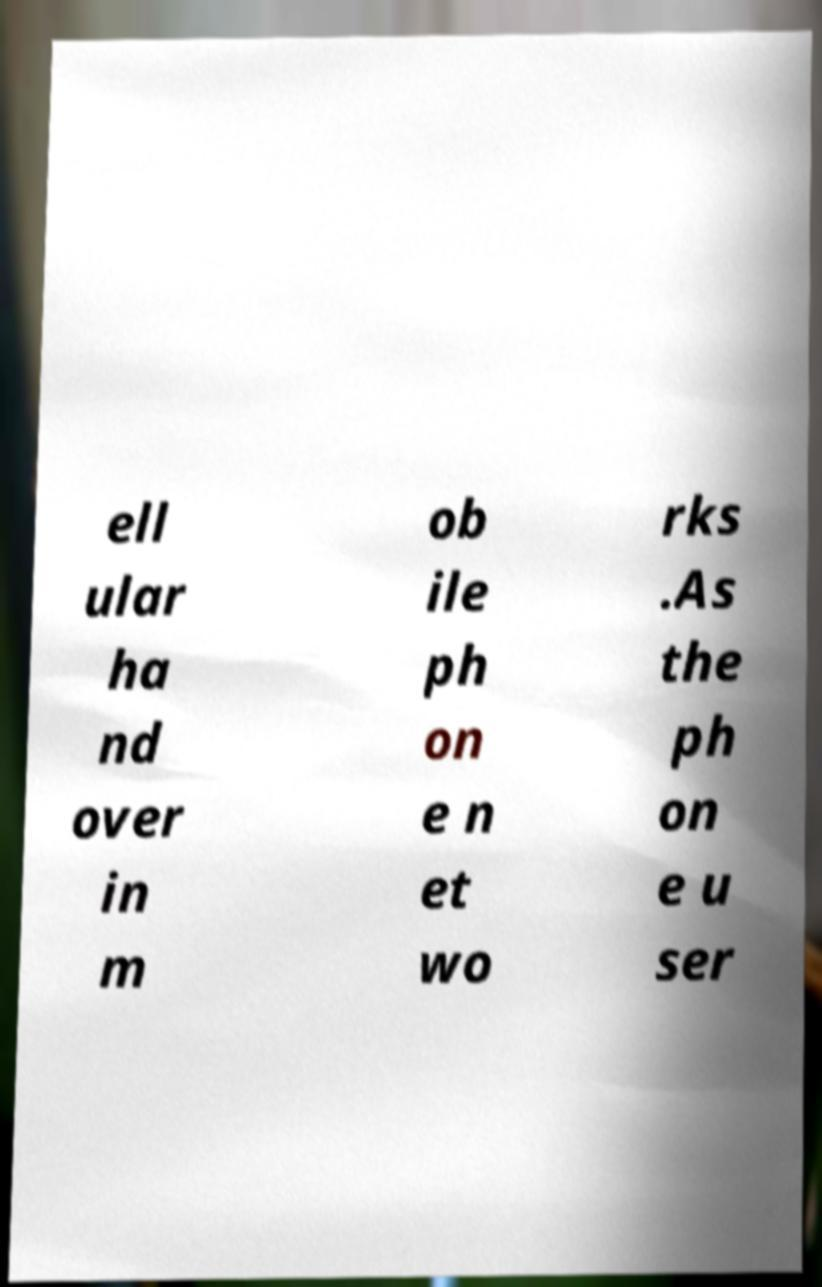Please read and relay the text visible in this image. What does it say? ell ular ha nd over in m ob ile ph on e n et wo rks .As the ph on e u ser 